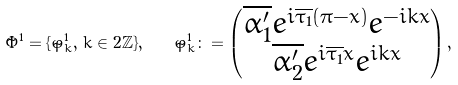<formula> <loc_0><loc_0><loc_500><loc_500>\tilde { \Phi } ^ { 1 } = \{ \tilde { \varphi } ^ { 1 } _ { k } , \, k \in 2 \mathbb { Z } \} , \quad \tilde { \varphi } ^ { 1 } _ { k } \colon = \begin{pmatrix} \overline { \alpha ^ { \prime } _ { 1 } } e ^ { i \overline { \tau _ { 1 } } ( \pi - x ) } e ^ { - i k x } \\ \overline { \alpha ^ { \prime } _ { 2 } } e ^ { i \overline { \tau _ { 1 } } x } e ^ { i k x } \end{pmatrix} ,</formula> 